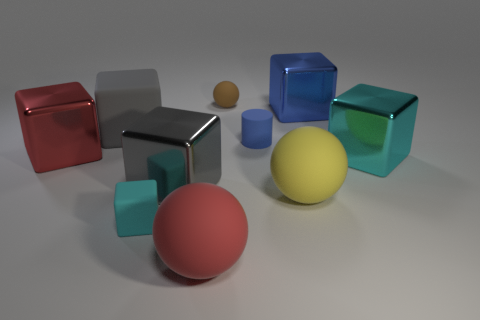Subtract all red spheres. How many spheres are left? 2 Subtract all brown balls. How many balls are left? 2 Subtract all green cylinders. How many cyan cubes are left? 2 Subtract all cylinders. How many objects are left? 9 Subtract 2 spheres. How many spheres are left? 1 Subtract all red cubes. Subtract all brown balls. How many cubes are left? 5 Subtract all blocks. Subtract all small green rubber cylinders. How many objects are left? 4 Add 8 big blue objects. How many big blue objects are left? 9 Add 1 cyan metal balls. How many cyan metal balls exist? 1 Subtract 0 yellow blocks. How many objects are left? 10 